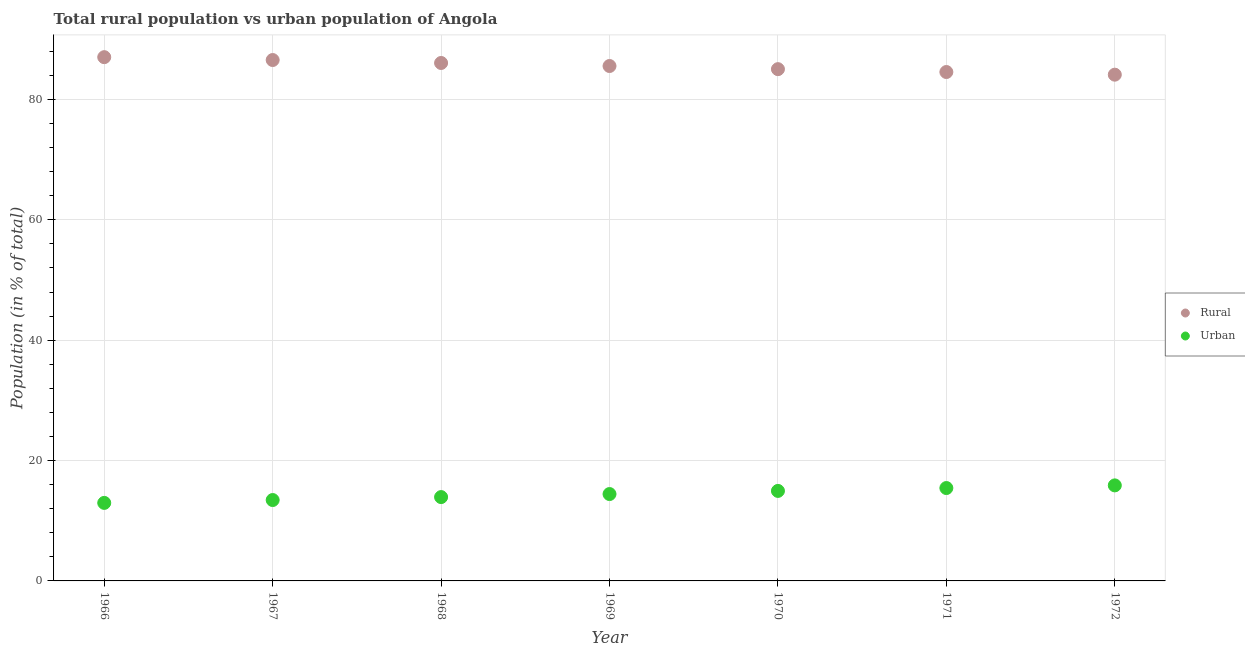What is the rural population in 1969?
Ensure brevity in your answer.  85.56. Across all years, what is the maximum rural population?
Keep it short and to the point. 87.03. Across all years, what is the minimum rural population?
Ensure brevity in your answer.  84.12. In which year was the urban population maximum?
Provide a succinct answer. 1972. In which year was the rural population minimum?
Your answer should be compact. 1972. What is the total urban population in the graph?
Your response must be concise. 101.04. What is the difference between the rural population in 1968 and that in 1972?
Offer a very short reply. 1.94. What is the difference between the urban population in 1972 and the rural population in 1970?
Keep it short and to the point. -69.17. What is the average rural population per year?
Your answer should be compact. 85.57. In the year 1972, what is the difference between the rural population and urban population?
Keep it short and to the point. 68.25. In how many years, is the urban population greater than 48 %?
Provide a succinct answer. 0. What is the ratio of the urban population in 1966 to that in 1968?
Offer a terse response. 0.93. Is the rural population in 1968 less than that in 1969?
Offer a terse response. No. What is the difference between the highest and the second highest rural population?
Your answer should be compact. 0.48. What is the difference between the highest and the lowest rural population?
Offer a very short reply. 2.91. In how many years, is the urban population greater than the average urban population taken over all years?
Your response must be concise. 4. Does the urban population monotonically increase over the years?
Offer a terse response. Yes. Is the urban population strictly less than the rural population over the years?
Give a very brief answer. Yes. How many dotlines are there?
Give a very brief answer. 2. How many years are there in the graph?
Your answer should be compact. 7. Are the values on the major ticks of Y-axis written in scientific E-notation?
Your answer should be very brief. No. How many legend labels are there?
Offer a terse response. 2. How are the legend labels stacked?
Make the answer very short. Vertical. What is the title of the graph?
Offer a terse response. Total rural population vs urban population of Angola. What is the label or title of the X-axis?
Offer a very short reply. Year. What is the label or title of the Y-axis?
Make the answer very short. Population (in % of total). What is the Population (in % of total) in Rural in 1966?
Make the answer very short. 87.03. What is the Population (in % of total) of Urban in 1966?
Your answer should be very brief. 12.96. What is the Population (in % of total) in Rural in 1967?
Your response must be concise. 86.56. What is the Population (in % of total) in Urban in 1967?
Ensure brevity in your answer.  13.44. What is the Population (in % of total) of Rural in 1968?
Make the answer very short. 86.07. What is the Population (in % of total) in Urban in 1968?
Your answer should be very brief. 13.93. What is the Population (in % of total) of Rural in 1969?
Provide a short and direct response. 85.56. What is the Population (in % of total) in Urban in 1969?
Provide a succinct answer. 14.44. What is the Population (in % of total) of Rural in 1970?
Your answer should be compact. 85.04. What is the Population (in % of total) of Urban in 1970?
Give a very brief answer. 14.96. What is the Population (in % of total) of Rural in 1971?
Keep it short and to the point. 84.57. What is the Population (in % of total) in Urban in 1971?
Provide a succinct answer. 15.43. What is the Population (in % of total) in Rural in 1972?
Give a very brief answer. 84.12. What is the Population (in % of total) in Urban in 1972?
Your response must be concise. 15.88. Across all years, what is the maximum Population (in % of total) of Rural?
Make the answer very short. 87.03. Across all years, what is the maximum Population (in % of total) of Urban?
Ensure brevity in your answer.  15.88. Across all years, what is the minimum Population (in % of total) of Rural?
Offer a terse response. 84.12. Across all years, what is the minimum Population (in % of total) in Urban?
Make the answer very short. 12.96. What is the total Population (in % of total) of Rural in the graph?
Your response must be concise. 598.96. What is the total Population (in % of total) in Urban in the graph?
Offer a terse response. 101.04. What is the difference between the Population (in % of total) in Rural in 1966 and that in 1967?
Provide a succinct answer. 0.48. What is the difference between the Population (in % of total) of Urban in 1966 and that in 1967?
Make the answer very short. -0.48. What is the difference between the Population (in % of total) of Urban in 1966 and that in 1968?
Ensure brevity in your answer.  -0.97. What is the difference between the Population (in % of total) of Rural in 1966 and that in 1969?
Give a very brief answer. 1.47. What is the difference between the Population (in % of total) of Urban in 1966 and that in 1969?
Make the answer very short. -1.47. What is the difference between the Population (in % of total) of Rural in 1966 and that in 1970?
Ensure brevity in your answer.  1.99. What is the difference between the Population (in % of total) in Urban in 1966 and that in 1970?
Make the answer very short. -1.99. What is the difference between the Population (in % of total) in Rural in 1966 and that in 1971?
Give a very brief answer. 2.47. What is the difference between the Population (in % of total) of Urban in 1966 and that in 1971?
Ensure brevity in your answer.  -2.47. What is the difference between the Population (in % of total) of Rural in 1966 and that in 1972?
Keep it short and to the point. 2.91. What is the difference between the Population (in % of total) in Urban in 1966 and that in 1972?
Your response must be concise. -2.91. What is the difference between the Population (in % of total) in Rural in 1967 and that in 1968?
Provide a succinct answer. 0.49. What is the difference between the Population (in % of total) of Urban in 1967 and that in 1968?
Make the answer very short. -0.49. What is the difference between the Population (in % of total) of Rural in 1967 and that in 1969?
Make the answer very short. 0.99. What is the difference between the Population (in % of total) in Urban in 1967 and that in 1969?
Your answer should be compact. -0.99. What is the difference between the Population (in % of total) of Rural in 1967 and that in 1970?
Your answer should be very brief. 1.52. What is the difference between the Population (in % of total) in Urban in 1967 and that in 1970?
Keep it short and to the point. -1.52. What is the difference between the Population (in % of total) of Rural in 1967 and that in 1971?
Offer a very short reply. 1.99. What is the difference between the Population (in % of total) of Urban in 1967 and that in 1971?
Your answer should be compact. -1.99. What is the difference between the Population (in % of total) of Rural in 1967 and that in 1972?
Make the answer very short. 2.43. What is the difference between the Population (in % of total) of Urban in 1967 and that in 1972?
Offer a terse response. -2.43. What is the difference between the Population (in % of total) of Rural in 1968 and that in 1969?
Make the answer very short. 0.5. What is the difference between the Population (in % of total) of Urban in 1968 and that in 1969?
Offer a terse response. -0.5. What is the difference between the Population (in % of total) in Rural in 1968 and that in 1970?
Give a very brief answer. 1.02. What is the difference between the Population (in % of total) in Urban in 1968 and that in 1970?
Provide a succinct answer. -1.02. What is the difference between the Population (in % of total) in Rural in 1968 and that in 1971?
Keep it short and to the point. 1.5. What is the difference between the Population (in % of total) of Urban in 1968 and that in 1971?
Ensure brevity in your answer.  -1.5. What is the difference between the Population (in % of total) in Rural in 1968 and that in 1972?
Your answer should be compact. 1.94. What is the difference between the Population (in % of total) of Urban in 1968 and that in 1972?
Make the answer very short. -1.94. What is the difference between the Population (in % of total) of Rural in 1969 and that in 1970?
Your answer should be compact. 0.52. What is the difference between the Population (in % of total) in Urban in 1969 and that in 1970?
Provide a short and direct response. -0.52. What is the difference between the Population (in % of total) of Rural in 1969 and that in 1971?
Your answer should be compact. 1. What is the difference between the Population (in % of total) in Urban in 1969 and that in 1971?
Make the answer very short. -1. What is the difference between the Population (in % of total) of Rural in 1969 and that in 1972?
Offer a very short reply. 1.44. What is the difference between the Population (in % of total) in Urban in 1969 and that in 1972?
Offer a very short reply. -1.44. What is the difference between the Population (in % of total) of Rural in 1970 and that in 1971?
Your response must be concise. 0.48. What is the difference between the Population (in % of total) in Urban in 1970 and that in 1971?
Keep it short and to the point. -0.48. What is the difference between the Population (in % of total) of Rural in 1970 and that in 1972?
Offer a very short reply. 0.92. What is the difference between the Population (in % of total) of Urban in 1970 and that in 1972?
Offer a very short reply. -0.92. What is the difference between the Population (in % of total) of Rural in 1971 and that in 1972?
Your response must be concise. 0.44. What is the difference between the Population (in % of total) of Urban in 1971 and that in 1972?
Your response must be concise. -0.44. What is the difference between the Population (in % of total) in Rural in 1966 and the Population (in % of total) in Urban in 1967?
Offer a very short reply. 73.59. What is the difference between the Population (in % of total) in Rural in 1966 and the Population (in % of total) in Urban in 1968?
Keep it short and to the point. 73.1. What is the difference between the Population (in % of total) in Rural in 1966 and the Population (in % of total) in Urban in 1969?
Your answer should be compact. 72.6. What is the difference between the Population (in % of total) of Rural in 1966 and the Population (in % of total) of Urban in 1970?
Keep it short and to the point. 72.08. What is the difference between the Population (in % of total) of Rural in 1966 and the Population (in % of total) of Urban in 1971?
Give a very brief answer. 71.6. What is the difference between the Population (in % of total) of Rural in 1966 and the Population (in % of total) of Urban in 1972?
Keep it short and to the point. 71.16. What is the difference between the Population (in % of total) in Rural in 1967 and the Population (in % of total) in Urban in 1968?
Give a very brief answer. 72.63. What is the difference between the Population (in % of total) of Rural in 1967 and the Population (in % of total) of Urban in 1969?
Offer a very short reply. 72.12. What is the difference between the Population (in % of total) of Rural in 1967 and the Population (in % of total) of Urban in 1970?
Provide a short and direct response. 71.6. What is the difference between the Population (in % of total) in Rural in 1967 and the Population (in % of total) in Urban in 1971?
Your response must be concise. 71.12. What is the difference between the Population (in % of total) of Rural in 1967 and the Population (in % of total) of Urban in 1972?
Give a very brief answer. 70.68. What is the difference between the Population (in % of total) in Rural in 1968 and the Population (in % of total) in Urban in 1969?
Provide a short and direct response. 71.63. What is the difference between the Population (in % of total) of Rural in 1968 and the Population (in % of total) of Urban in 1970?
Offer a very short reply. 71.11. What is the difference between the Population (in % of total) of Rural in 1968 and the Population (in % of total) of Urban in 1971?
Your answer should be compact. 70.63. What is the difference between the Population (in % of total) in Rural in 1968 and the Population (in % of total) in Urban in 1972?
Offer a very short reply. 70.19. What is the difference between the Population (in % of total) of Rural in 1969 and the Population (in % of total) of Urban in 1970?
Your response must be concise. 70.61. What is the difference between the Population (in % of total) in Rural in 1969 and the Population (in % of total) in Urban in 1971?
Your answer should be very brief. 70.13. What is the difference between the Population (in % of total) in Rural in 1969 and the Population (in % of total) in Urban in 1972?
Your answer should be compact. 69.69. What is the difference between the Population (in % of total) of Rural in 1970 and the Population (in % of total) of Urban in 1971?
Offer a very short reply. 69.61. What is the difference between the Population (in % of total) of Rural in 1970 and the Population (in % of total) of Urban in 1972?
Keep it short and to the point. 69.17. What is the difference between the Population (in % of total) in Rural in 1971 and the Population (in % of total) in Urban in 1972?
Offer a terse response. 68.69. What is the average Population (in % of total) in Rural per year?
Ensure brevity in your answer.  85.57. What is the average Population (in % of total) in Urban per year?
Offer a terse response. 14.43. In the year 1966, what is the difference between the Population (in % of total) in Rural and Population (in % of total) in Urban?
Offer a terse response. 74.07. In the year 1967, what is the difference between the Population (in % of total) of Rural and Population (in % of total) of Urban?
Offer a terse response. 73.12. In the year 1968, what is the difference between the Population (in % of total) of Rural and Population (in % of total) of Urban?
Provide a short and direct response. 72.14. In the year 1969, what is the difference between the Population (in % of total) of Rural and Population (in % of total) of Urban?
Provide a succinct answer. 71.13. In the year 1970, what is the difference between the Population (in % of total) of Rural and Population (in % of total) of Urban?
Keep it short and to the point. 70.09. In the year 1971, what is the difference between the Population (in % of total) in Rural and Population (in % of total) in Urban?
Offer a terse response. 69.13. In the year 1972, what is the difference between the Population (in % of total) in Rural and Population (in % of total) in Urban?
Keep it short and to the point. 68.25. What is the ratio of the Population (in % of total) in Urban in 1966 to that in 1967?
Your response must be concise. 0.96. What is the ratio of the Population (in % of total) in Rural in 1966 to that in 1968?
Your response must be concise. 1.01. What is the ratio of the Population (in % of total) in Urban in 1966 to that in 1968?
Make the answer very short. 0.93. What is the ratio of the Population (in % of total) in Rural in 1966 to that in 1969?
Provide a succinct answer. 1.02. What is the ratio of the Population (in % of total) of Urban in 1966 to that in 1969?
Keep it short and to the point. 0.9. What is the ratio of the Population (in % of total) of Rural in 1966 to that in 1970?
Your response must be concise. 1.02. What is the ratio of the Population (in % of total) in Urban in 1966 to that in 1970?
Ensure brevity in your answer.  0.87. What is the ratio of the Population (in % of total) in Rural in 1966 to that in 1971?
Keep it short and to the point. 1.03. What is the ratio of the Population (in % of total) in Urban in 1966 to that in 1971?
Your response must be concise. 0.84. What is the ratio of the Population (in % of total) of Rural in 1966 to that in 1972?
Your response must be concise. 1.03. What is the ratio of the Population (in % of total) of Urban in 1966 to that in 1972?
Your answer should be very brief. 0.82. What is the ratio of the Population (in % of total) in Urban in 1967 to that in 1968?
Keep it short and to the point. 0.96. What is the ratio of the Population (in % of total) in Rural in 1967 to that in 1969?
Offer a terse response. 1.01. What is the ratio of the Population (in % of total) in Urban in 1967 to that in 1969?
Provide a short and direct response. 0.93. What is the ratio of the Population (in % of total) in Rural in 1967 to that in 1970?
Make the answer very short. 1.02. What is the ratio of the Population (in % of total) in Urban in 1967 to that in 1970?
Your answer should be compact. 0.9. What is the ratio of the Population (in % of total) in Rural in 1967 to that in 1971?
Your answer should be compact. 1.02. What is the ratio of the Population (in % of total) of Urban in 1967 to that in 1971?
Offer a terse response. 0.87. What is the ratio of the Population (in % of total) of Rural in 1967 to that in 1972?
Your answer should be very brief. 1.03. What is the ratio of the Population (in % of total) of Urban in 1967 to that in 1972?
Make the answer very short. 0.85. What is the ratio of the Population (in % of total) in Rural in 1968 to that in 1969?
Make the answer very short. 1.01. What is the ratio of the Population (in % of total) in Urban in 1968 to that in 1969?
Your response must be concise. 0.97. What is the ratio of the Population (in % of total) in Rural in 1968 to that in 1970?
Provide a short and direct response. 1.01. What is the ratio of the Population (in % of total) in Urban in 1968 to that in 1970?
Your response must be concise. 0.93. What is the ratio of the Population (in % of total) of Rural in 1968 to that in 1971?
Your answer should be compact. 1.02. What is the ratio of the Population (in % of total) in Urban in 1968 to that in 1971?
Make the answer very short. 0.9. What is the ratio of the Population (in % of total) of Rural in 1968 to that in 1972?
Your response must be concise. 1.02. What is the ratio of the Population (in % of total) of Urban in 1968 to that in 1972?
Offer a very short reply. 0.88. What is the ratio of the Population (in % of total) in Urban in 1969 to that in 1970?
Ensure brevity in your answer.  0.97. What is the ratio of the Population (in % of total) in Rural in 1969 to that in 1971?
Provide a succinct answer. 1.01. What is the ratio of the Population (in % of total) in Urban in 1969 to that in 1971?
Your answer should be very brief. 0.94. What is the ratio of the Population (in % of total) of Rural in 1969 to that in 1972?
Provide a succinct answer. 1.02. What is the ratio of the Population (in % of total) in Urban in 1969 to that in 1972?
Provide a short and direct response. 0.91. What is the ratio of the Population (in % of total) of Rural in 1970 to that in 1971?
Offer a terse response. 1.01. What is the ratio of the Population (in % of total) of Urban in 1970 to that in 1971?
Keep it short and to the point. 0.97. What is the ratio of the Population (in % of total) of Rural in 1970 to that in 1972?
Give a very brief answer. 1.01. What is the ratio of the Population (in % of total) in Urban in 1970 to that in 1972?
Your response must be concise. 0.94. What is the ratio of the Population (in % of total) of Urban in 1971 to that in 1972?
Offer a very short reply. 0.97. What is the difference between the highest and the second highest Population (in % of total) in Rural?
Make the answer very short. 0.48. What is the difference between the highest and the second highest Population (in % of total) in Urban?
Make the answer very short. 0.44. What is the difference between the highest and the lowest Population (in % of total) in Rural?
Make the answer very short. 2.91. What is the difference between the highest and the lowest Population (in % of total) of Urban?
Your answer should be very brief. 2.91. 